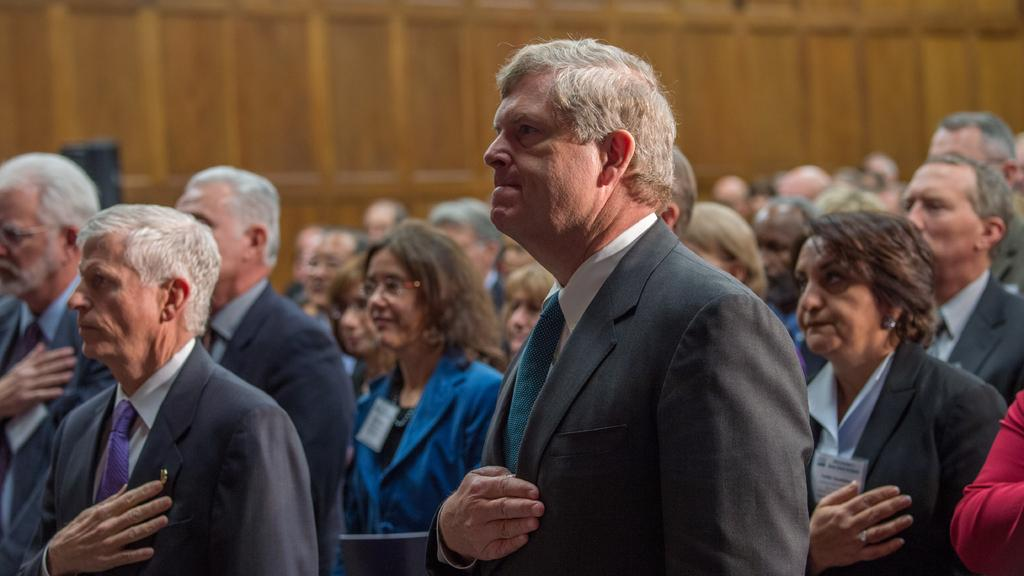What is happening in the image with the group of people? The people in the image are standing and putting their hands on their hearts. What can be seen in the background of the image? There is a wooden wall in the background of the image. What type of tiger can be seen hiding behind the wooden wall in the image? There is no tiger present in the image; it only features a group of people standing with their hands on their hearts and a wooden wall in the background. 